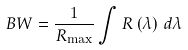Convert formula to latex. <formula><loc_0><loc_0><loc_500><loc_500>B W = \frac { 1 } { { R _ { \max } } } \int { R \left ( { \lambda } \right ) \, d \lambda }</formula> 